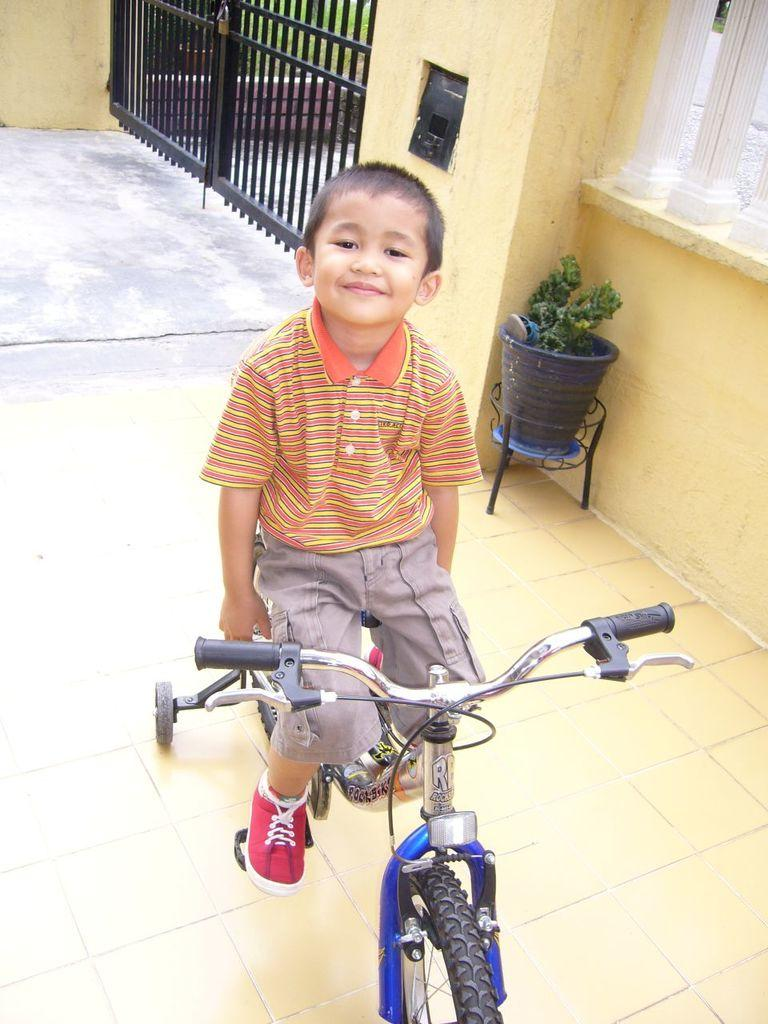Who is the main subject in the image? There is a boy in the image. What is the boy doing in the image? The boy is sitting on a bicycle. What is the boy's facial expression in the image? The boy is smiling. What can be seen in the background of the image? There is a gate with a lock, a flower pot with a plant, and a chapel in the background. Does the boy in the image express any regret about his actions? There is no indication of regret in the boy's facial expression or actions in the image. 